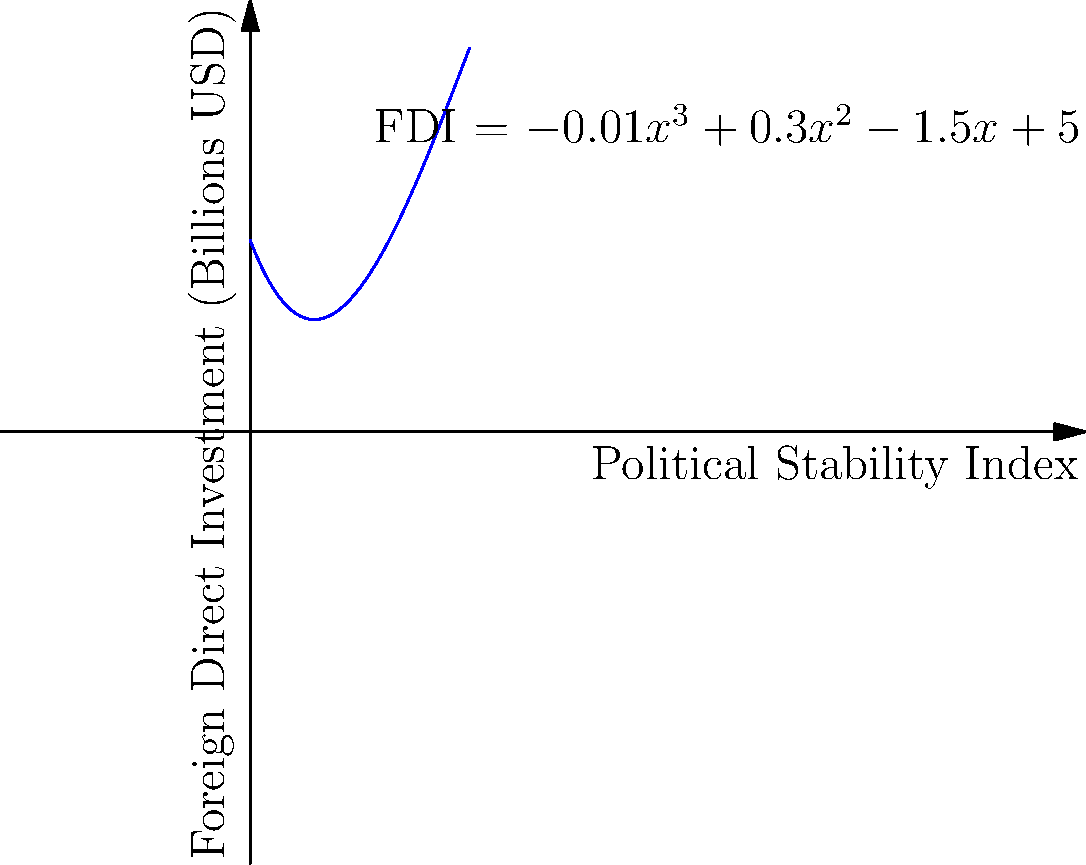The graph shows a polynomial regression analysis of the relationship between political stability and foreign direct investment (FDI). Given the equation $FDI = -0.01x^3 + 0.3x^2 - 1.5x + 5$, where $x$ represents the Political Stability Index, at what value of $x$ does FDI reach its maximum? To find the maximum point of the FDI function, we need to follow these steps:

1) First, we need to find the derivative of the function:
   $\frac{d(FDI)}{dx} = -0.03x^2 + 0.6x - 1.5$

2) To find the maximum, we set the derivative equal to zero and solve for x:
   $-0.03x^2 + 0.6x - 1.5 = 0$

3) This is a quadratic equation. We can solve it using the quadratic formula:
   $x = \frac{-b \pm \sqrt{b^2 - 4ac}}{2a}$

   Where $a = -0.03$, $b = 0.6$, and $c = -1.5$

4) Plugging these values into the quadratic formula:
   $x = \frac{-0.6 \pm \sqrt{0.6^2 - 4(-0.03)(-1.5)}}{2(-0.03)}$

5) Simplifying:
   $x = \frac{-0.6 \pm \sqrt{0.36 - 0.18}}{-0.06} = \frac{-0.6 \pm \sqrt{0.18}}{-0.06}$

6) This gives us two solutions:
   $x_1 \approx 1.37$ and $x_2 \approx 8.63$

7) To determine which of these is the maximum (rather than the minimum), we can check the second derivative:
   $\frac{d^2(FDI)}{dx^2} = -0.06x + 0.6$

8) Evaluating this at our two critical points:
   At $x = 1.37$: $-0.06(1.37) + 0.6 = 0.52$ (positive, so this is a minimum)
   At $x = 8.63$: $-0.06(8.63) + 0.6 = -0.12$ (negative, so this is a maximum)

Therefore, FDI reaches its maximum when the Political Stability Index is approximately 8.63.
Answer: 8.63 